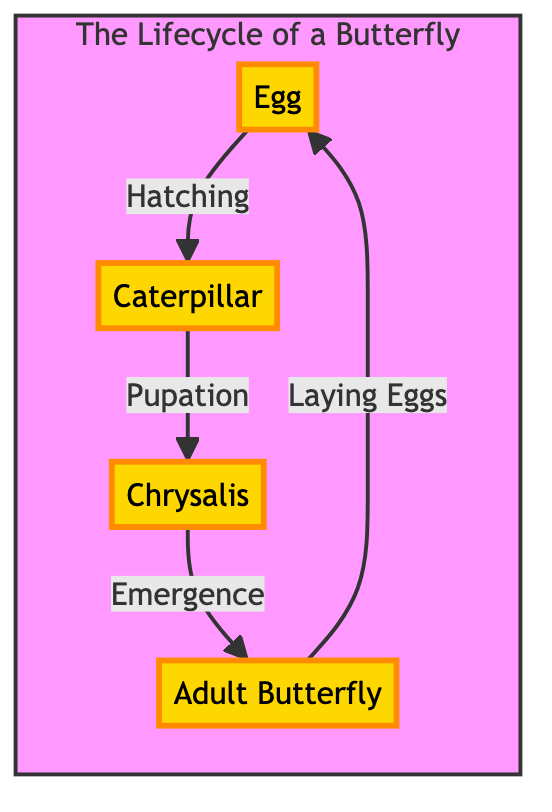What are the four stages in the lifecycle of a butterfly? The diagram shows four stages: Egg, Caterpillar, Chrysalis, and Adult Butterfly. These are directly labeled in the diagram.
Answer: Egg, Caterpillar, Chrysalis, Adult Butterfly Which stage comes after the Caterpillar? The directed arrow from the Caterpillar leads to the Chrysalis, indicating that the next stage after the Caterpillar is the Chrysalis.
Answer: Chrysalis How many stages are there in total? By counting the labeled stages in the diagram, there are four distinct stages shown: Egg, Caterpillar, Chrysalis, and Adult Butterfly.
Answer: 4 What process occurs during the transition from Chrysalis to Adult Butterfly? The arrow from Chrysalis to Adult Butterfly is labeled "Emergence," indicating that this is the process that takes place during this transition.
Answer: Emergence Which stage is the starting point of the lifecycle? The diagram starts with the Egg, as it is the first node in the circular progression of the lifecycle.
Answer: Egg What relationship is described between the Adult Butterfly and the Egg? The arrow labeled "Laying Eggs" points from the Adult Butterfly back to the Egg, showing that the relationship involves the Adult Butterfly laying eggs.
Answer: Laying Eggs What is the transition process from Egg to Caterpillar? The arrow from the Egg to the Caterpillar is labeled "Hatching," indicating that this is the transition process between these two stages.
Answer: Hatching Which stage leads directly to the Caterpillar? The diagram shows that the Egg leads directly to the Caterpillar through the hatching process indicated by the arrow.
Answer: Egg Which stage follows the Chrysalis? Following the arrow from the Chrysalis shows that the next stage is the Adult Butterfly, which directly succeeds the Chrysalis.
Answer: Adult Butterfly 